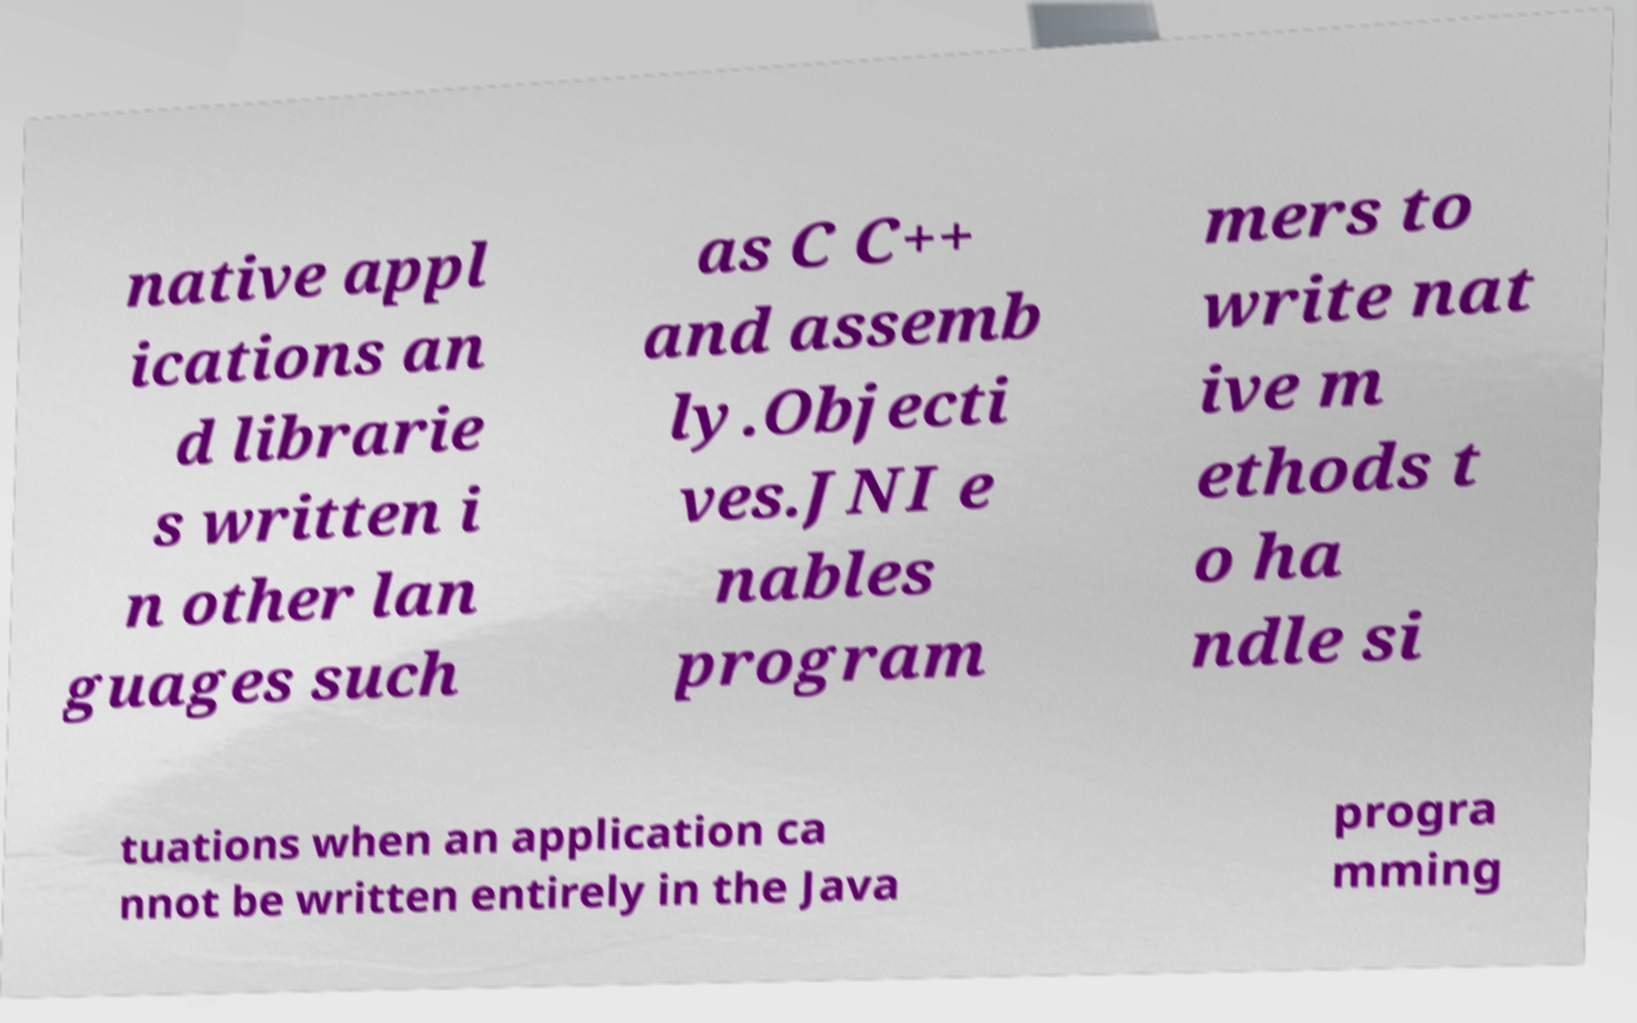There's text embedded in this image that I need extracted. Can you transcribe it verbatim? native appl ications an d librarie s written i n other lan guages such as C C++ and assemb ly.Objecti ves.JNI e nables program mers to write nat ive m ethods t o ha ndle si tuations when an application ca nnot be written entirely in the Java progra mming 